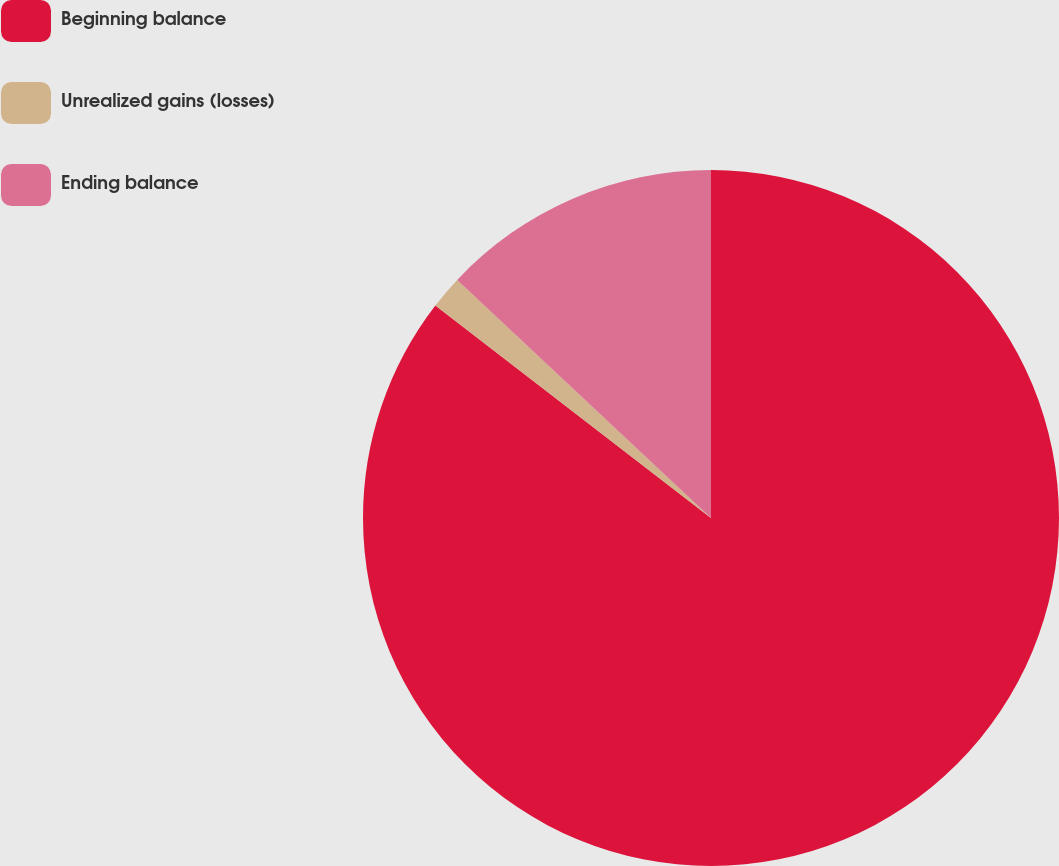<chart> <loc_0><loc_0><loc_500><loc_500><pie_chart><fcel>Beginning balance<fcel>Unrealized gains (losses)<fcel>Ending balance<nl><fcel>85.46%<fcel>1.54%<fcel>13.01%<nl></chart> 